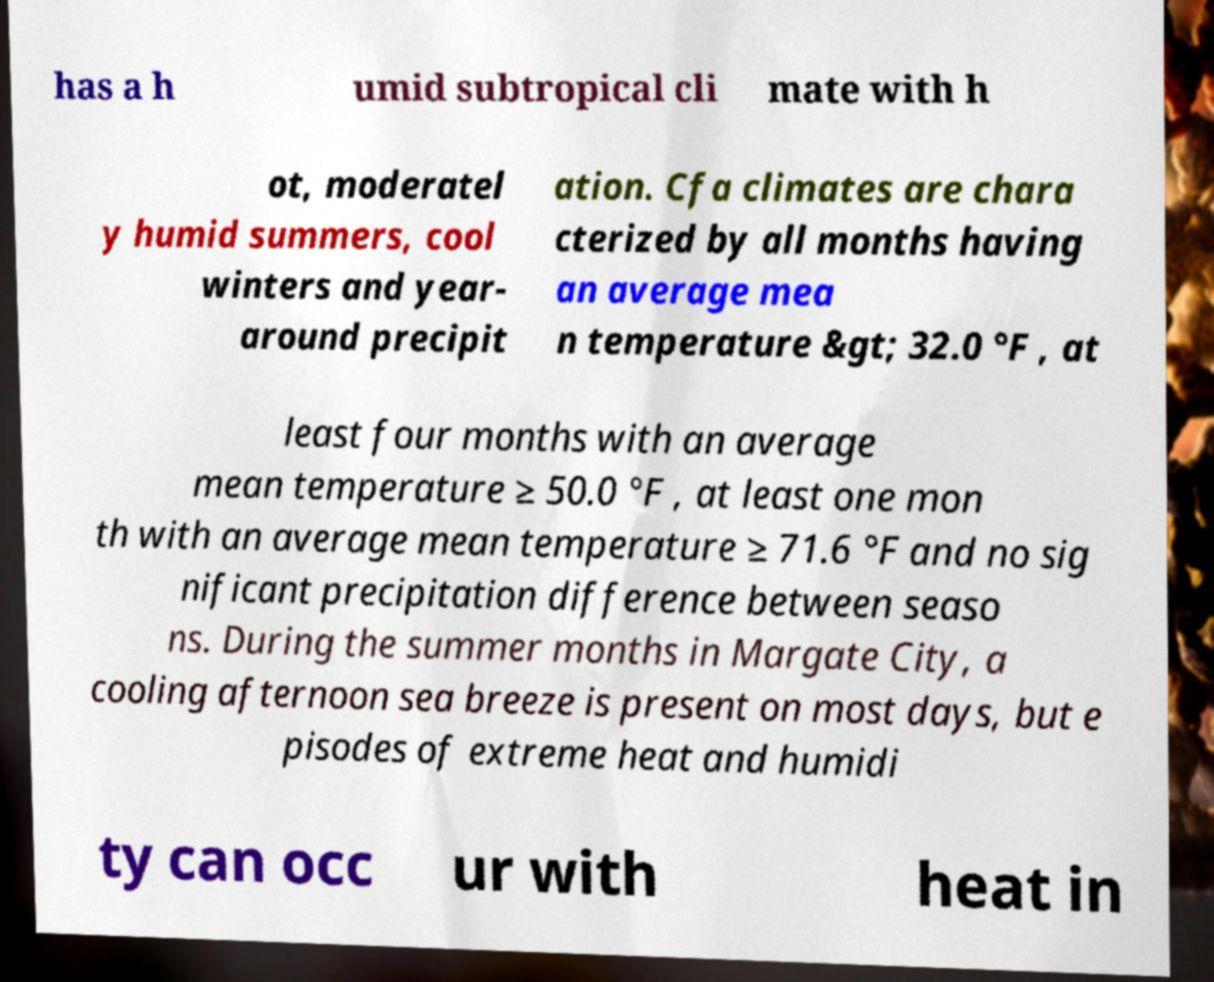Can you accurately transcribe the text from the provided image for me? has a h umid subtropical cli mate with h ot, moderatel y humid summers, cool winters and year- around precipit ation. Cfa climates are chara cterized by all months having an average mea n temperature &gt; 32.0 °F , at least four months with an average mean temperature ≥ 50.0 °F , at least one mon th with an average mean temperature ≥ 71.6 °F and no sig nificant precipitation difference between seaso ns. During the summer months in Margate City, a cooling afternoon sea breeze is present on most days, but e pisodes of extreme heat and humidi ty can occ ur with heat in 